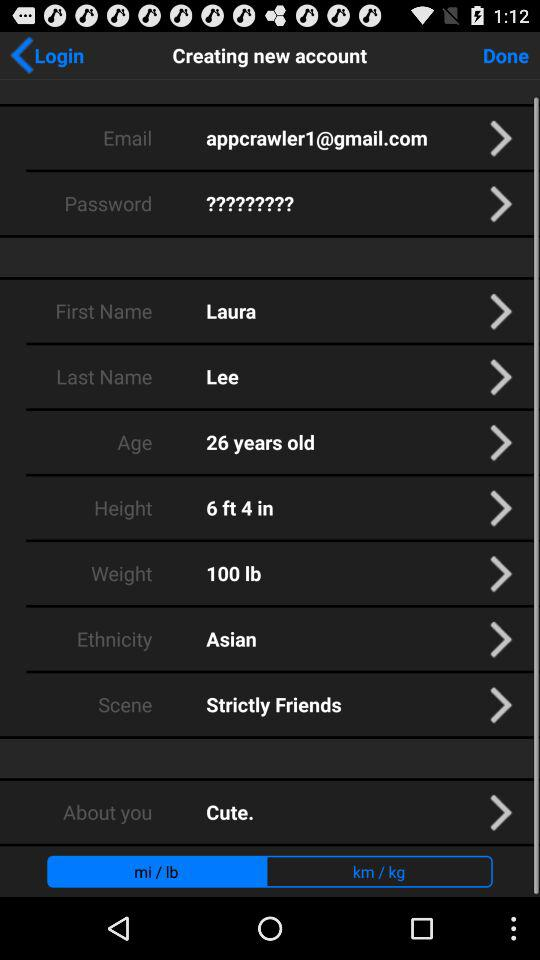What is the first name? The first name is Laura. 